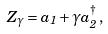<formula> <loc_0><loc_0><loc_500><loc_500>Z _ { \gamma } = a _ { 1 } + \gamma a _ { 2 } ^ { \dag } \, ,</formula> 